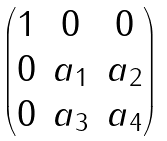<formula> <loc_0><loc_0><loc_500><loc_500>\begin{pmatrix} 1 & 0 & 0 \\ 0 & a _ { 1 } & a _ { 2 } \\ 0 & a _ { 3 } & a _ { 4 } \end{pmatrix}</formula> 